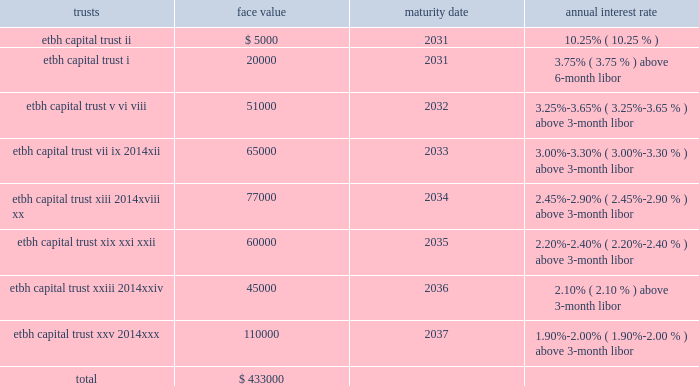Fhlb advances and other borrowings fhlb advances 2014the company had $ 0.7 billion and $ 0.5 billion in floating-rate and $ 0.2 billion and $ 1.8 billion in fixed-rate fhlb advances at december 31 , 2012 and 2011 , respectively .
The floating-rate advances adjust quarterly based on the libor .
During the year ended december 31 , 2012 , $ 650.0 million of fixed-rate fhlb advances were converted to floating-rate for a total cost of approximately $ 128 million which was capitalized and will be amortized over the remaining maturities using the effective interest method .
In addition , during the year ended december 31 , 2012 , the company paid down in advance of maturity $ 1.0 billion of its fhlb advances and recorded $ 69.1 million in losses on the early extinguishment .
This loss was recorded in the gains ( losses ) on early extinguishment of debt line item in the consolidated statement of income ( loss ) .
The company did not have any similar transactions for the years ended december 31 , 2011 and 2010 .
As a condition of its membership in the fhlb atlanta , the company is required to maintain a fhlb stock investment currently equal to the lesser of : a percentage of 0.2% ( 0.2 % ) of total bank assets ; or a dollar cap amount of $ 26 million .
Additionally , the bank must maintain an activity based stock investment which is currently equal to 4.5% ( 4.5 % ) of the bank 2019s outstanding advances at the time of borrowing .
On a quarterly basis , the fhlb atlanta evaluates excess activity based stock holdings for its members and makes a determination regarding quarterly redemption of any excess activity based stock positions .
The company had an investment in fhlb stock of $ 67.4 million and $ 140.2 million at december 31 , 2012 and 2011 , respectively .
The company must also maintain qualified collateral as a percent of its advances , which varies based on the collateral type , and is further adjusted by the outcome of the most recent annual collateral audit and by fhlb 2019s internal ranking of the bank 2019s creditworthiness .
These advances are secured by a pool of mortgage loans and mortgage-backed securities .
At december 31 , 2012 and 2011 , the company pledged loans with a lendable value of $ 4.8 billion and $ 5.0 billion , respectively , of the one- to four-family and home equity loans as collateral in support of both its advances and unused borrowing lines .
Other borrowings 2014prior to 2008 , etbh raised capital through the formation of trusts , which sold trust preferred securities in the capital markets .
The capital securities must be redeemed in whole at the due date , which is generally 30 years after issuance .
Each trust issued floating rate cumulative preferred securities ( 201ctrust preferred securities 201d ) , at par with a liquidation amount of $ 1000 per capital security .
The trusts used the proceeds from the sale of issuances to purchase floating rate junior subordinated debentures ( 201csubordinated debentures 201d ) issued by etbh , which guarantees the trust obligations and contributed proceeds from the sale of its subordinated debentures to e*trade bank in the form of a capital contribution .
The most recent issuance of trust preferred securities occurred in 2007 .
The face values of outstanding trusts at december 31 , 2012 are shown below ( dollars in thousands ) : trusts face value maturity date annual interest rate .
As of december 31 , 2011 , other borrowings also included $ 2.3 million of collateral pledged to the bank by its derivatives counterparties to reduce credit exposure to changes in market value .
The company did not have any similar borrowings for the year ended december 31 , 2012. .
At december 31 , 2012 what was the ratio of the face values of outstanding trusts with a maturity in 2037 to 2033? 
Rationale: at december 31 , 2012 the ratio of the face values of outstanding trusts with a maturity in 2037 to 2033 was 1.69 to 1
Computations: (110000 / 65000)
Answer: 1.69231. 